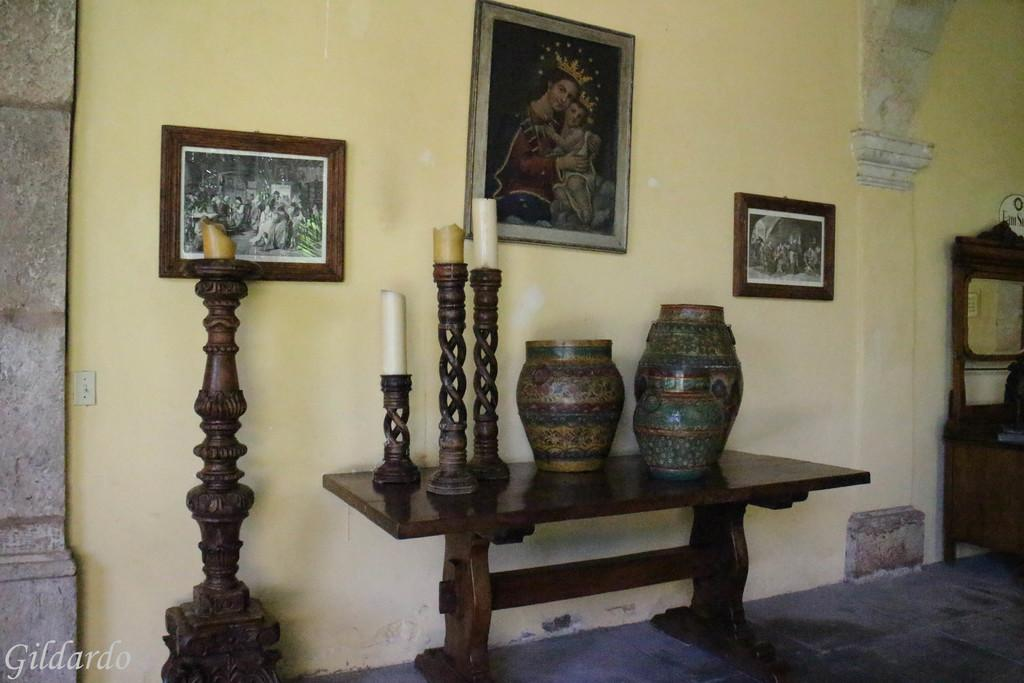What color is the wall that is visible in the image? There is a yellow color wall in the image. What objects can be seen hanging on the wall in the image? There are photo frames in the image. What piece of furniture is present in the image? There is a table in the image. What items are placed on the table in the image? There are candles and pots on the table in the image. What type of knowledge is being shared by the candles in the image? The candles in the image are not sharing any knowledge; they are inanimate objects. 